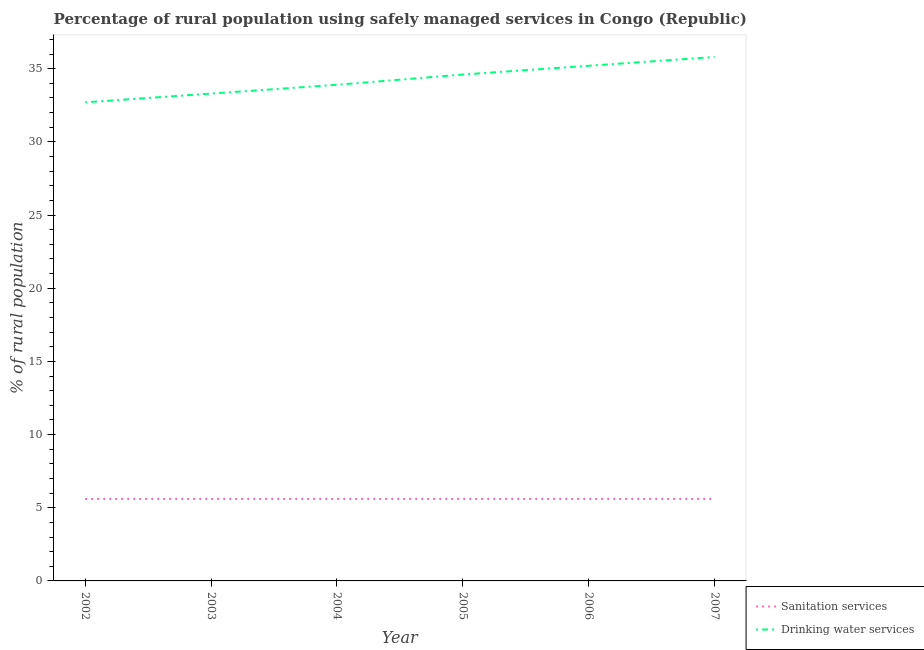How many different coloured lines are there?
Your answer should be very brief. 2. Does the line corresponding to percentage of rural population who used drinking water services intersect with the line corresponding to percentage of rural population who used sanitation services?
Make the answer very short. No. What is the percentage of rural population who used drinking water services in 2004?
Give a very brief answer. 33.9. In which year was the percentage of rural population who used sanitation services maximum?
Keep it short and to the point. 2002. What is the total percentage of rural population who used drinking water services in the graph?
Provide a succinct answer. 205.5. What is the difference between the percentage of rural population who used drinking water services in 2003 and that in 2004?
Provide a short and direct response. -0.6. What is the average percentage of rural population who used drinking water services per year?
Make the answer very short. 34.25. In the year 2005, what is the difference between the percentage of rural population who used sanitation services and percentage of rural population who used drinking water services?
Give a very brief answer. -29. In how many years, is the percentage of rural population who used sanitation services greater than 30 %?
Provide a succinct answer. 0. What is the ratio of the percentage of rural population who used drinking water services in 2003 to that in 2005?
Offer a terse response. 0.96. Is the difference between the percentage of rural population who used drinking water services in 2004 and 2005 greater than the difference between the percentage of rural population who used sanitation services in 2004 and 2005?
Give a very brief answer. No. What is the difference between the highest and the lowest percentage of rural population who used drinking water services?
Your answer should be compact. 3.1. In how many years, is the percentage of rural population who used drinking water services greater than the average percentage of rural population who used drinking water services taken over all years?
Ensure brevity in your answer.  3. Is the sum of the percentage of rural population who used drinking water services in 2002 and 2007 greater than the maximum percentage of rural population who used sanitation services across all years?
Provide a succinct answer. Yes. Does the percentage of rural population who used drinking water services monotonically increase over the years?
Your response must be concise. Yes. Is the percentage of rural population who used drinking water services strictly less than the percentage of rural population who used sanitation services over the years?
Offer a very short reply. No. How many years are there in the graph?
Provide a short and direct response. 6. What is the difference between two consecutive major ticks on the Y-axis?
Provide a succinct answer. 5. Are the values on the major ticks of Y-axis written in scientific E-notation?
Your answer should be compact. No. Where does the legend appear in the graph?
Provide a succinct answer. Bottom right. What is the title of the graph?
Offer a terse response. Percentage of rural population using safely managed services in Congo (Republic). Does "ODA received" appear as one of the legend labels in the graph?
Your response must be concise. No. What is the label or title of the X-axis?
Your answer should be very brief. Year. What is the label or title of the Y-axis?
Keep it short and to the point. % of rural population. What is the % of rural population of Sanitation services in 2002?
Offer a terse response. 5.6. What is the % of rural population in Drinking water services in 2002?
Make the answer very short. 32.7. What is the % of rural population in Sanitation services in 2003?
Offer a terse response. 5.6. What is the % of rural population in Drinking water services in 2003?
Give a very brief answer. 33.3. What is the % of rural population in Drinking water services in 2004?
Make the answer very short. 33.9. What is the % of rural population of Drinking water services in 2005?
Keep it short and to the point. 34.6. What is the % of rural population in Drinking water services in 2006?
Give a very brief answer. 35.2. What is the % of rural population of Drinking water services in 2007?
Keep it short and to the point. 35.8. Across all years, what is the maximum % of rural population in Drinking water services?
Keep it short and to the point. 35.8. Across all years, what is the minimum % of rural population of Drinking water services?
Provide a short and direct response. 32.7. What is the total % of rural population of Sanitation services in the graph?
Your response must be concise. 33.6. What is the total % of rural population of Drinking water services in the graph?
Your answer should be compact. 205.5. What is the difference between the % of rural population of Sanitation services in 2002 and that in 2003?
Keep it short and to the point. 0. What is the difference between the % of rural population in Drinking water services in 2002 and that in 2004?
Provide a short and direct response. -1.2. What is the difference between the % of rural population of Sanitation services in 2002 and that in 2005?
Offer a very short reply. 0. What is the difference between the % of rural population of Sanitation services in 2002 and that in 2006?
Keep it short and to the point. 0. What is the difference between the % of rural population of Drinking water services in 2002 and that in 2007?
Make the answer very short. -3.1. What is the difference between the % of rural population of Sanitation services in 2003 and that in 2004?
Provide a short and direct response. 0. What is the difference between the % of rural population of Drinking water services in 2003 and that in 2004?
Provide a short and direct response. -0.6. What is the difference between the % of rural population of Sanitation services in 2003 and that in 2005?
Provide a short and direct response. 0. What is the difference between the % of rural population of Drinking water services in 2003 and that in 2005?
Keep it short and to the point. -1.3. What is the difference between the % of rural population in Sanitation services in 2003 and that in 2006?
Provide a succinct answer. 0. What is the difference between the % of rural population of Sanitation services in 2003 and that in 2007?
Your answer should be compact. 0. What is the difference between the % of rural population in Drinking water services in 2003 and that in 2007?
Offer a terse response. -2.5. What is the difference between the % of rural population in Sanitation services in 2004 and that in 2005?
Make the answer very short. 0. What is the difference between the % of rural population in Drinking water services in 2004 and that in 2005?
Your answer should be very brief. -0.7. What is the difference between the % of rural population of Sanitation services in 2004 and that in 2006?
Provide a short and direct response. 0. What is the difference between the % of rural population in Drinking water services in 2004 and that in 2007?
Provide a short and direct response. -1.9. What is the difference between the % of rural population of Drinking water services in 2005 and that in 2007?
Provide a succinct answer. -1.2. What is the difference between the % of rural population in Sanitation services in 2002 and the % of rural population in Drinking water services in 2003?
Ensure brevity in your answer.  -27.7. What is the difference between the % of rural population in Sanitation services in 2002 and the % of rural population in Drinking water services in 2004?
Give a very brief answer. -28.3. What is the difference between the % of rural population in Sanitation services in 2002 and the % of rural population in Drinking water services in 2006?
Offer a very short reply. -29.6. What is the difference between the % of rural population of Sanitation services in 2002 and the % of rural population of Drinking water services in 2007?
Provide a succinct answer. -30.2. What is the difference between the % of rural population of Sanitation services in 2003 and the % of rural population of Drinking water services in 2004?
Offer a very short reply. -28.3. What is the difference between the % of rural population in Sanitation services in 2003 and the % of rural population in Drinking water services in 2005?
Provide a short and direct response. -29. What is the difference between the % of rural population of Sanitation services in 2003 and the % of rural population of Drinking water services in 2006?
Provide a short and direct response. -29.6. What is the difference between the % of rural population of Sanitation services in 2003 and the % of rural population of Drinking water services in 2007?
Your answer should be very brief. -30.2. What is the difference between the % of rural population in Sanitation services in 2004 and the % of rural population in Drinking water services in 2005?
Your response must be concise. -29. What is the difference between the % of rural population in Sanitation services in 2004 and the % of rural population in Drinking water services in 2006?
Ensure brevity in your answer.  -29.6. What is the difference between the % of rural population of Sanitation services in 2004 and the % of rural population of Drinking water services in 2007?
Your response must be concise. -30.2. What is the difference between the % of rural population of Sanitation services in 2005 and the % of rural population of Drinking water services in 2006?
Give a very brief answer. -29.6. What is the difference between the % of rural population in Sanitation services in 2005 and the % of rural population in Drinking water services in 2007?
Your response must be concise. -30.2. What is the difference between the % of rural population in Sanitation services in 2006 and the % of rural population in Drinking water services in 2007?
Offer a very short reply. -30.2. What is the average % of rural population in Drinking water services per year?
Ensure brevity in your answer.  34.25. In the year 2002, what is the difference between the % of rural population of Sanitation services and % of rural population of Drinking water services?
Provide a succinct answer. -27.1. In the year 2003, what is the difference between the % of rural population of Sanitation services and % of rural population of Drinking water services?
Offer a very short reply. -27.7. In the year 2004, what is the difference between the % of rural population of Sanitation services and % of rural population of Drinking water services?
Offer a terse response. -28.3. In the year 2006, what is the difference between the % of rural population of Sanitation services and % of rural population of Drinking water services?
Ensure brevity in your answer.  -29.6. In the year 2007, what is the difference between the % of rural population of Sanitation services and % of rural population of Drinking water services?
Provide a succinct answer. -30.2. What is the ratio of the % of rural population of Sanitation services in 2002 to that in 2003?
Keep it short and to the point. 1. What is the ratio of the % of rural population of Drinking water services in 2002 to that in 2003?
Your response must be concise. 0.98. What is the ratio of the % of rural population of Drinking water services in 2002 to that in 2004?
Your answer should be compact. 0.96. What is the ratio of the % of rural population of Drinking water services in 2002 to that in 2005?
Provide a short and direct response. 0.95. What is the ratio of the % of rural population of Sanitation services in 2002 to that in 2006?
Your response must be concise. 1. What is the ratio of the % of rural population in Drinking water services in 2002 to that in 2006?
Ensure brevity in your answer.  0.93. What is the ratio of the % of rural population of Drinking water services in 2002 to that in 2007?
Provide a short and direct response. 0.91. What is the ratio of the % of rural population in Drinking water services in 2003 to that in 2004?
Provide a short and direct response. 0.98. What is the ratio of the % of rural population in Drinking water services in 2003 to that in 2005?
Provide a short and direct response. 0.96. What is the ratio of the % of rural population of Drinking water services in 2003 to that in 2006?
Offer a very short reply. 0.95. What is the ratio of the % of rural population in Drinking water services in 2003 to that in 2007?
Provide a short and direct response. 0.93. What is the ratio of the % of rural population in Sanitation services in 2004 to that in 2005?
Make the answer very short. 1. What is the ratio of the % of rural population in Drinking water services in 2004 to that in 2005?
Give a very brief answer. 0.98. What is the ratio of the % of rural population in Sanitation services in 2004 to that in 2006?
Provide a succinct answer. 1. What is the ratio of the % of rural population in Drinking water services in 2004 to that in 2006?
Offer a very short reply. 0.96. What is the ratio of the % of rural population in Drinking water services in 2004 to that in 2007?
Make the answer very short. 0.95. What is the ratio of the % of rural population in Sanitation services in 2005 to that in 2006?
Your answer should be compact. 1. What is the ratio of the % of rural population of Drinking water services in 2005 to that in 2007?
Provide a short and direct response. 0.97. What is the ratio of the % of rural population in Sanitation services in 2006 to that in 2007?
Keep it short and to the point. 1. What is the ratio of the % of rural population in Drinking water services in 2006 to that in 2007?
Keep it short and to the point. 0.98. What is the difference between the highest and the second highest % of rural population in Sanitation services?
Your response must be concise. 0. 